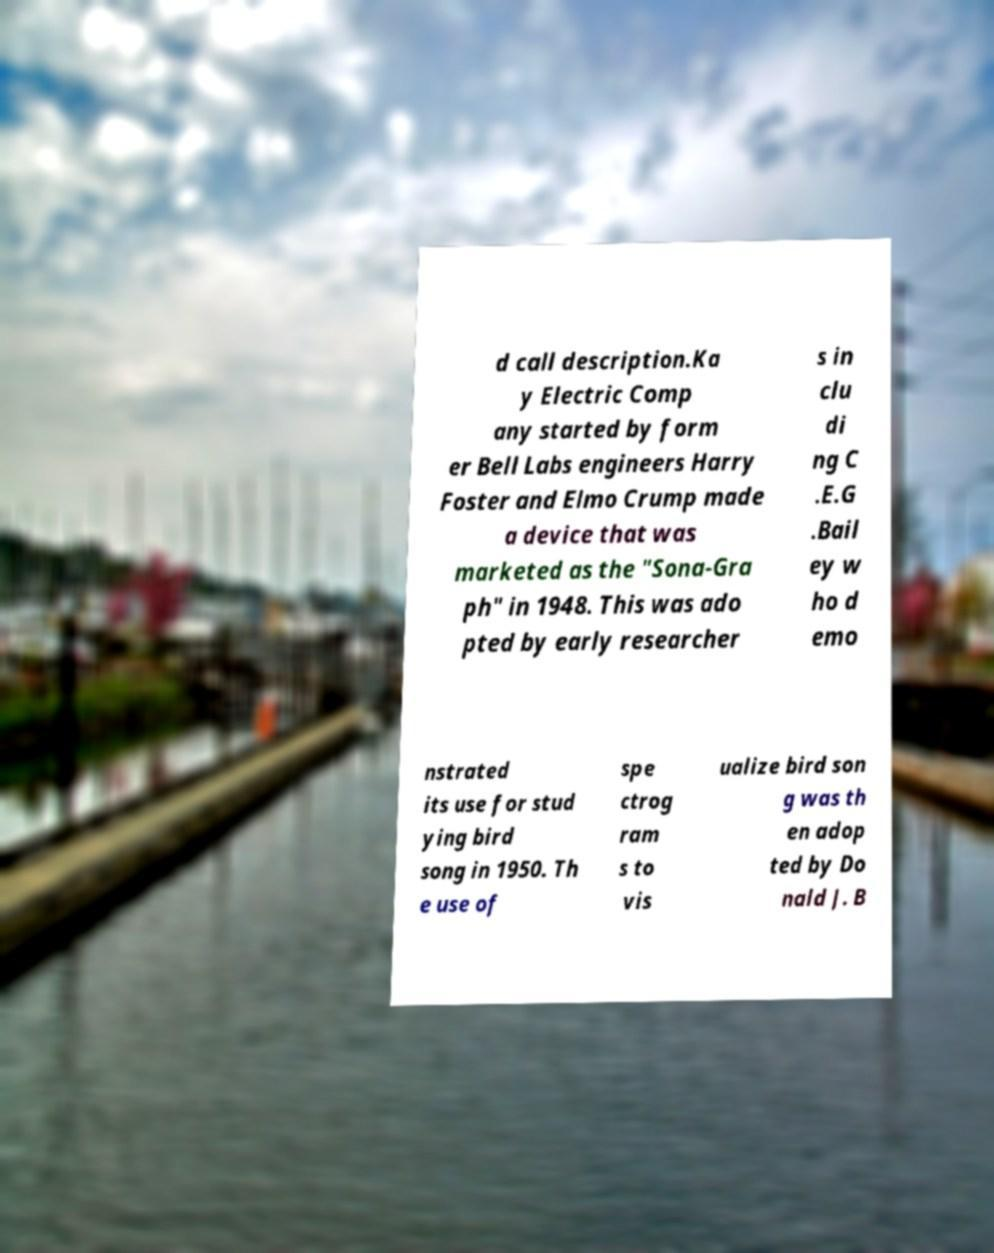Please read and relay the text visible in this image. What does it say? d call description.Ka y Electric Comp any started by form er Bell Labs engineers Harry Foster and Elmo Crump made a device that was marketed as the "Sona-Gra ph" in 1948. This was ado pted by early researcher s in clu di ng C .E.G .Bail ey w ho d emo nstrated its use for stud ying bird song in 1950. Th e use of spe ctrog ram s to vis ualize bird son g was th en adop ted by Do nald J. B 